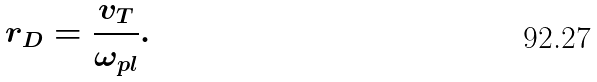<formula> <loc_0><loc_0><loc_500><loc_500>r _ { D } = \frac { v _ { T } } { \omega _ { p l } } .</formula> 